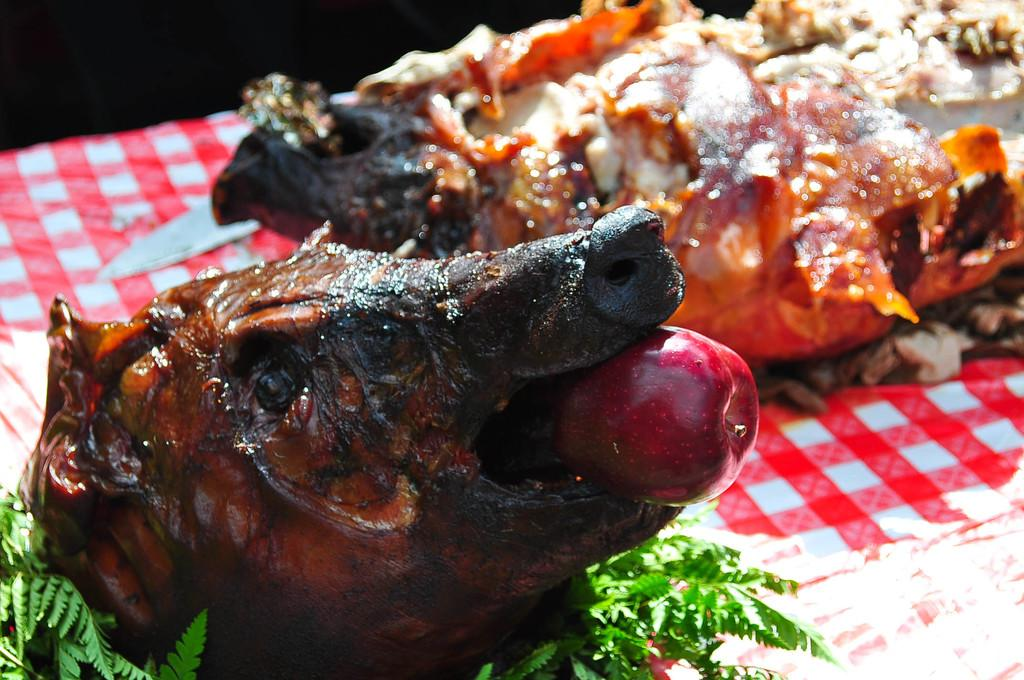What type of food is on the table in the image? There is meat on the table in the image. What fruit is on the table? There is an apple on the table. What type of plant material is on the table? There are leaves on the table. Whose foot is visible under the table in the image? There are no feet visible in the image; it only shows items on the table. 